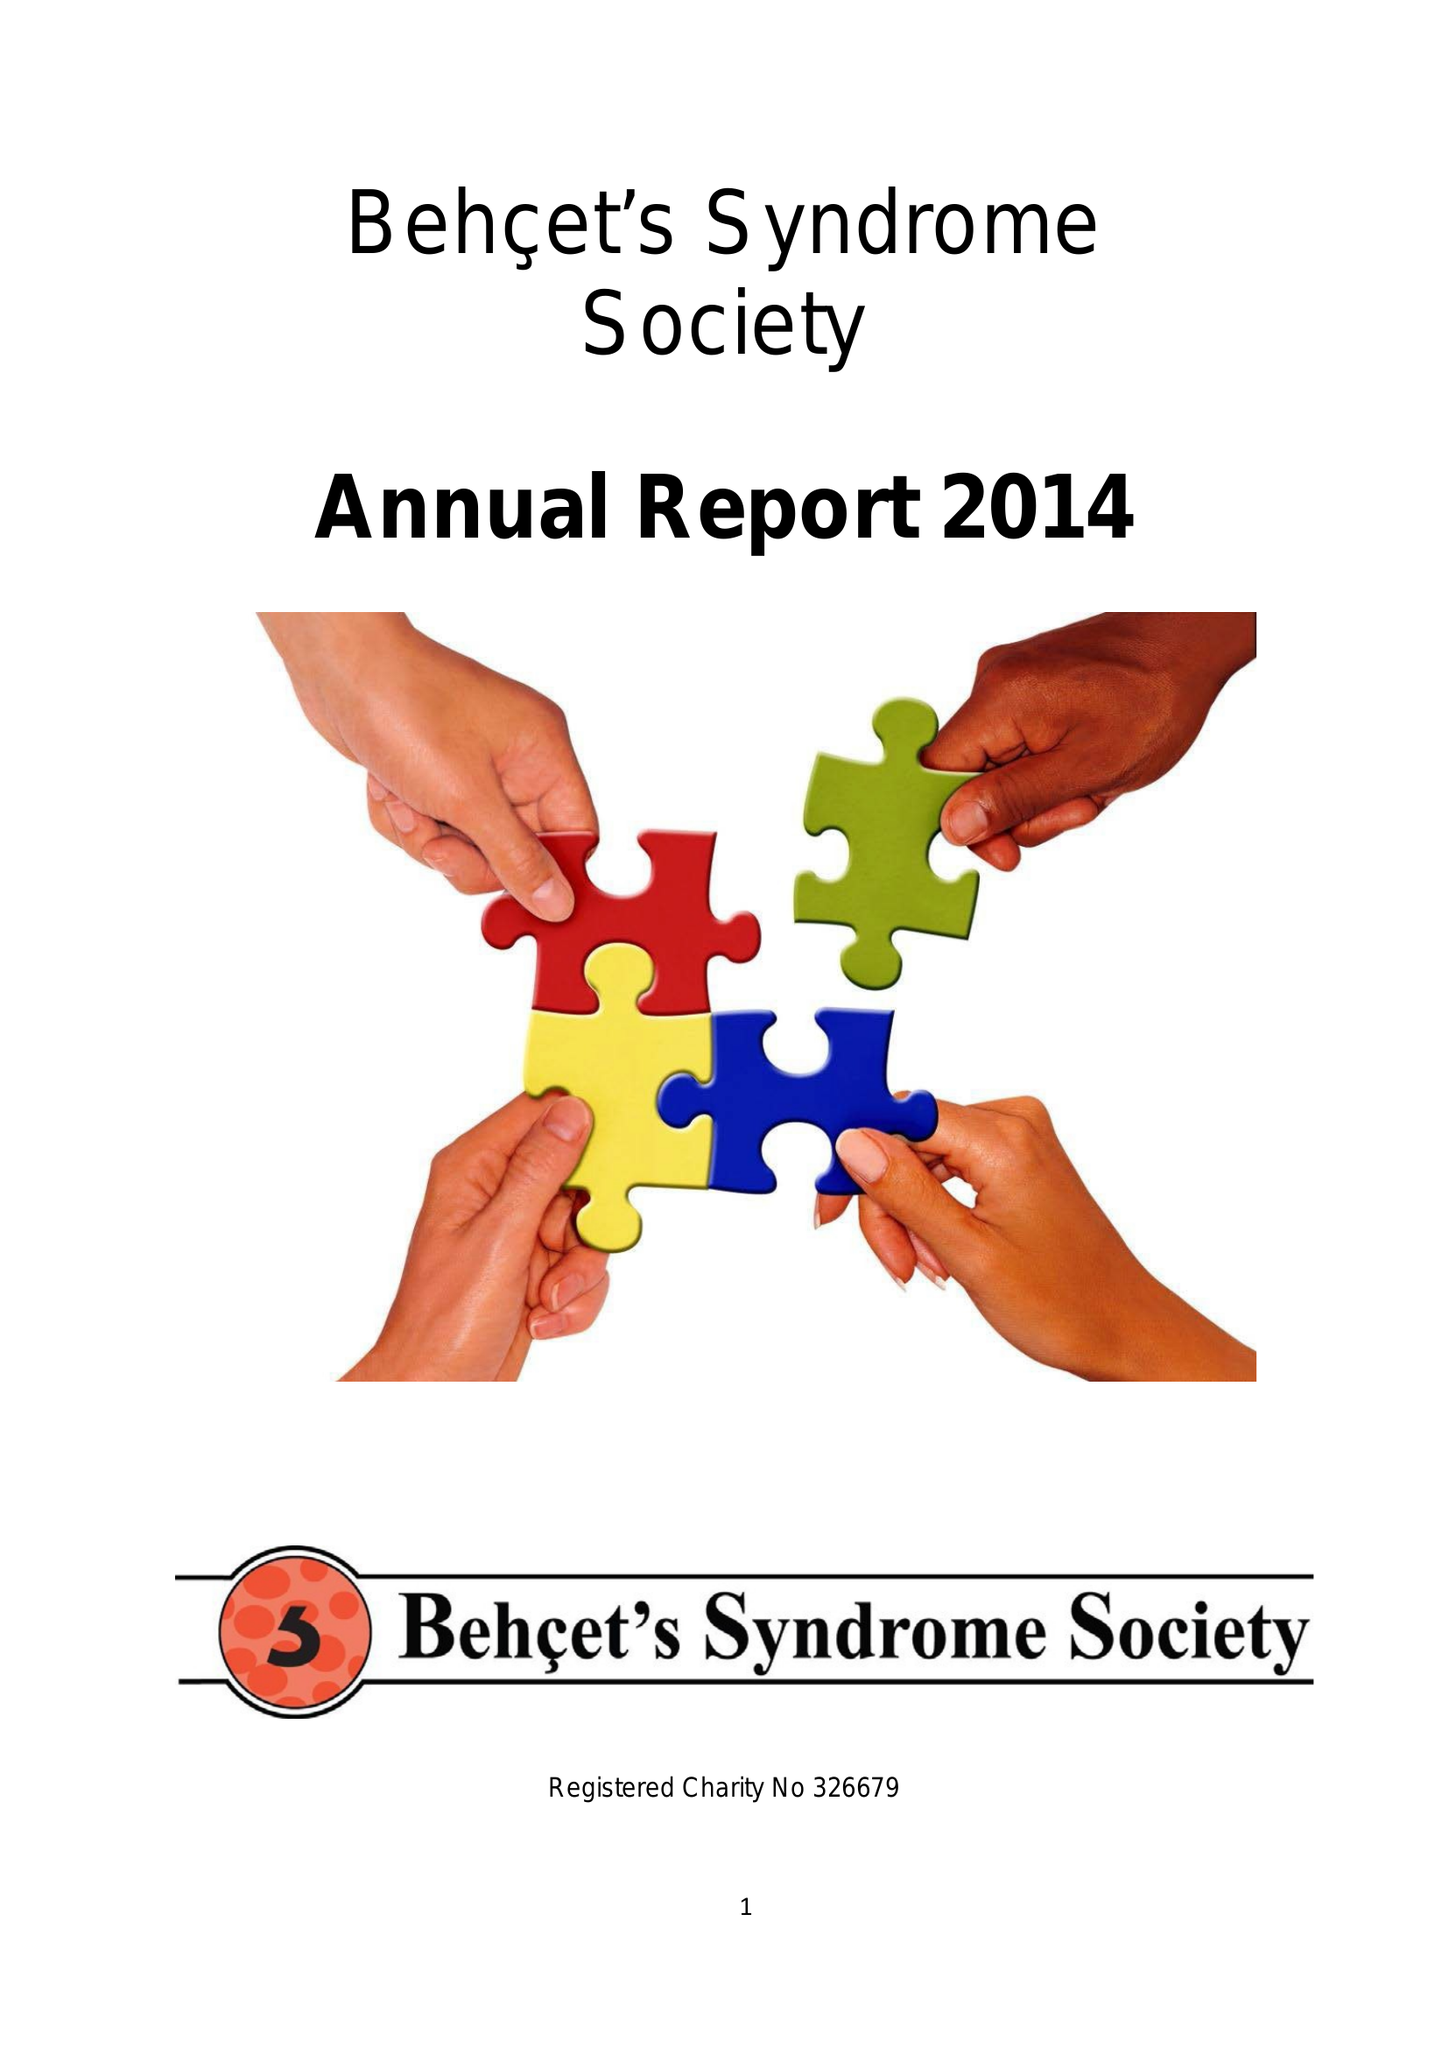What is the value for the spending_annually_in_british_pounds?
Answer the question using a single word or phrase. 52198.00 